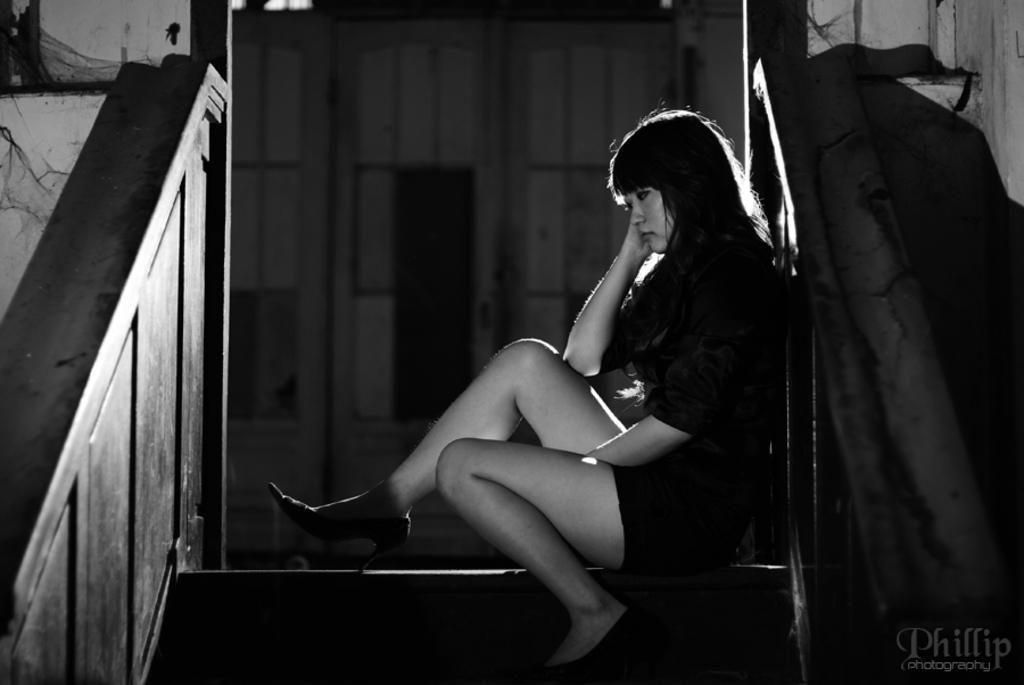In one or two sentences, can you explain what this image depicts? In the foreground I can see a woman is sitting on a staircase. In the background I can see a house and a door. This image is taken may be during night. 